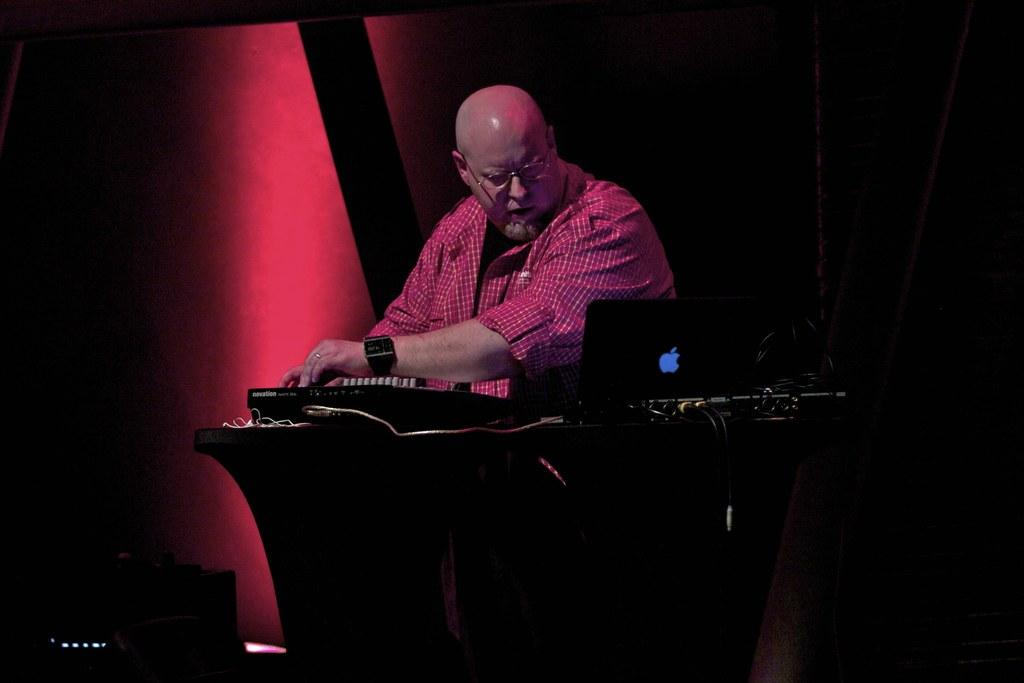Who is in the image? There is a person in the image. What is the person wearing? The person is wearing a red checked shirt and spectacles. What accessory is the person wearing on their wrist? The person is wearing a watch. What is on the table in the image? There is a laptop, wires, and other items on the table. What type of music can be heard playing in the background of the image? There is no music playing in the background of the image; it is a still image. 